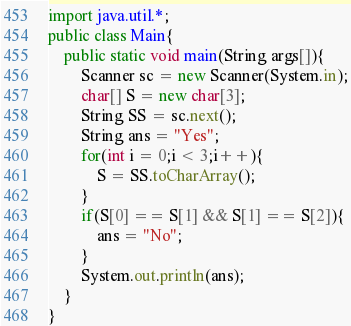<code> <loc_0><loc_0><loc_500><loc_500><_Java_>import java.util.*;
public class Main{
	public static void main(String args[]){
		Scanner sc = new Scanner(System.in);
		char[] S = new char[3];
		String SS = sc.next();
		String ans = "Yes";
		for(int i = 0;i < 3;i++){
			S = SS.toCharArray();
		}
		if(S[0] == S[1] && S[1] == S[2]){
			ans = "No";
		}
		System.out.println(ans);
	}
}</code> 